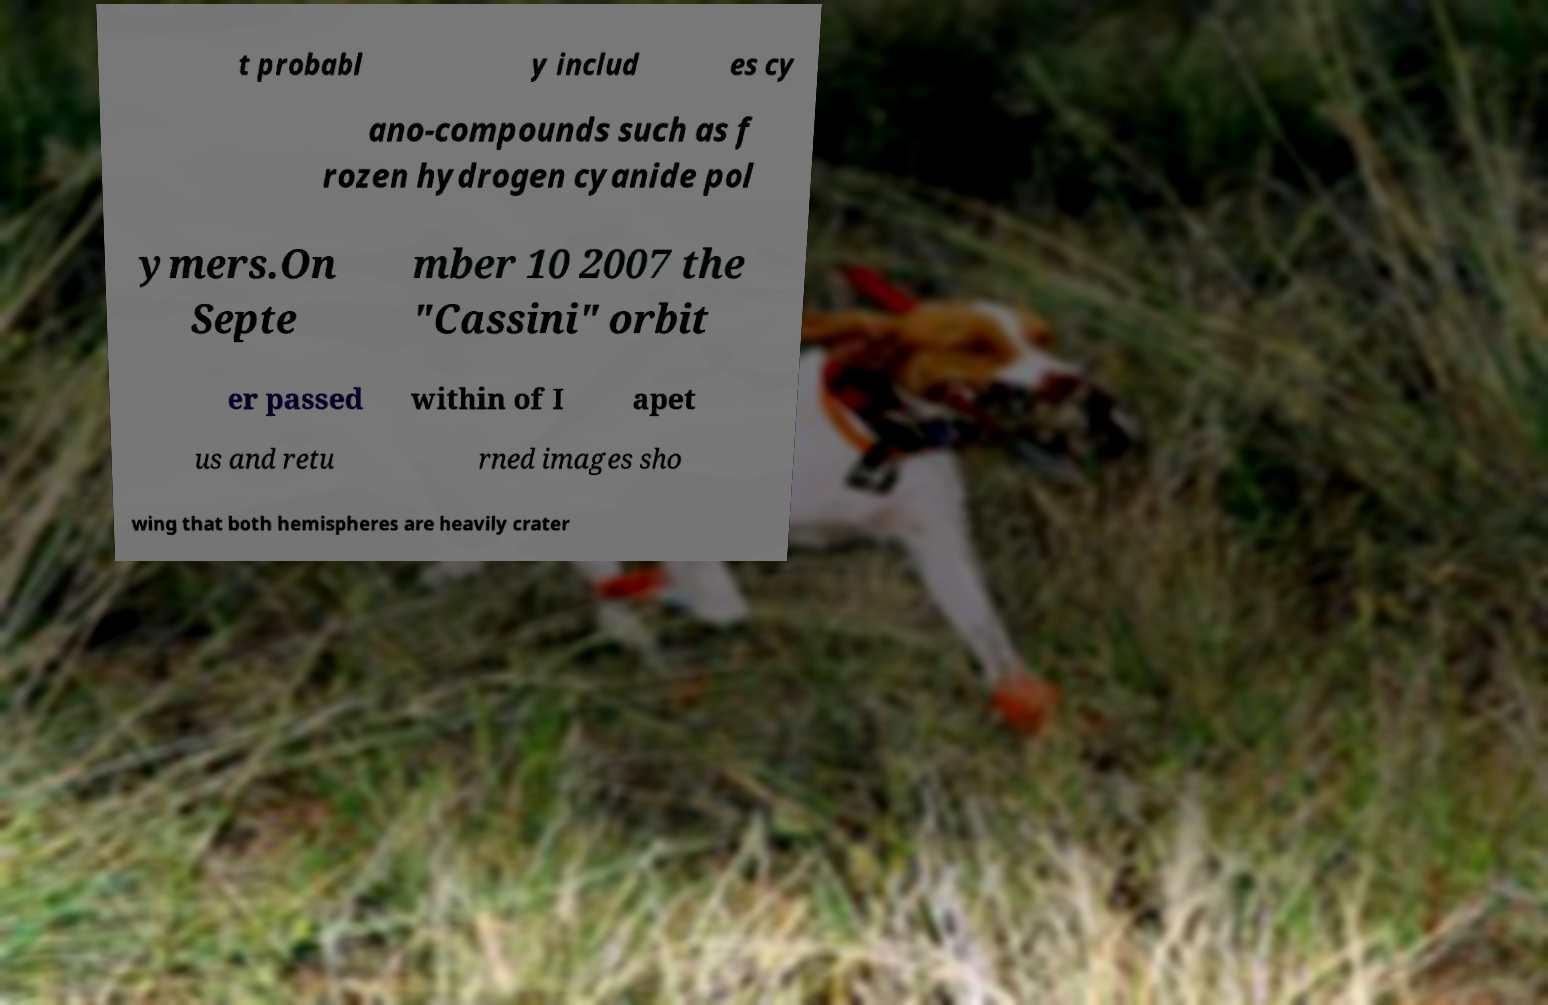Please identify and transcribe the text found in this image. t probabl y includ es cy ano-compounds such as f rozen hydrogen cyanide pol ymers.On Septe mber 10 2007 the "Cassini" orbit er passed within of I apet us and retu rned images sho wing that both hemispheres are heavily crater 